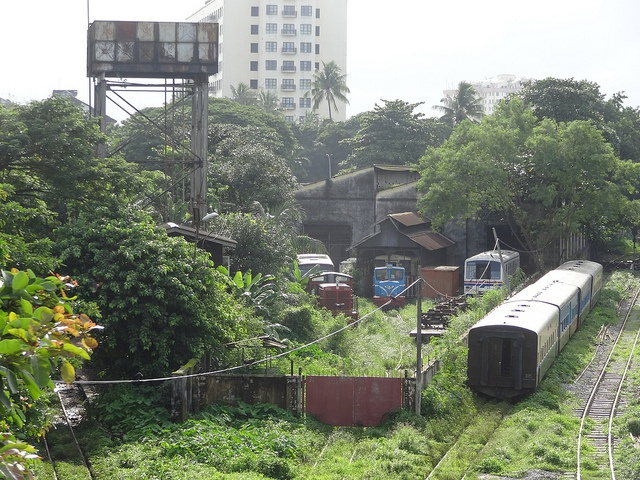Describe the objects in this image and their specific colors. I can see train in white, black, gray, and darkgray tones, train in white, gray, darkgray, and lightgray tones, and bus in white, gray, and darkgray tones in this image. 